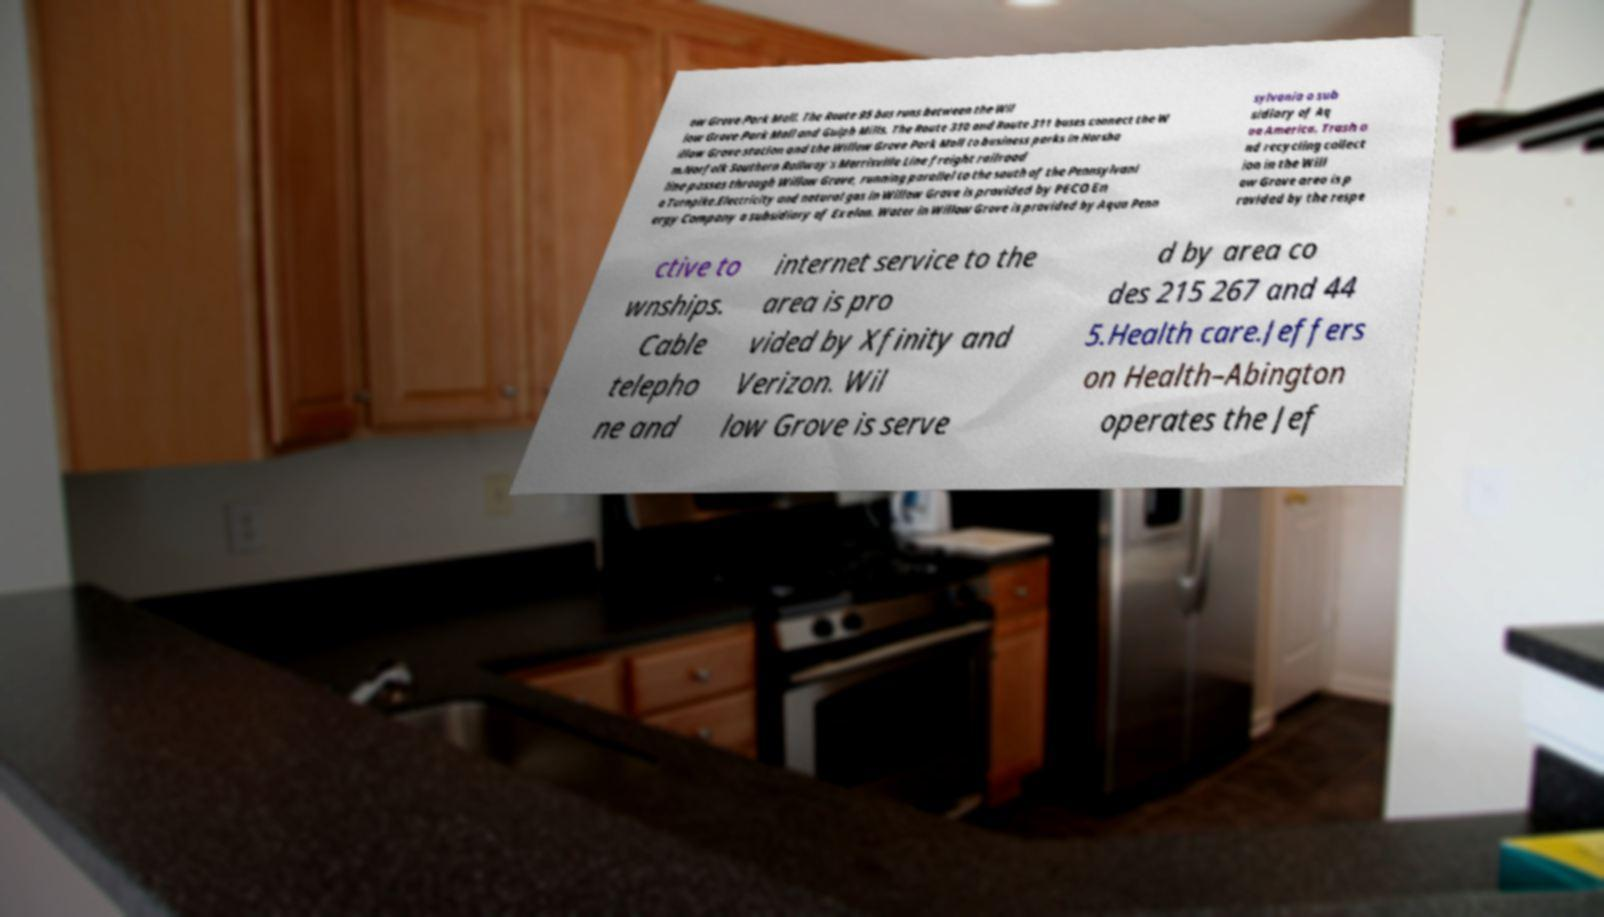What messages or text are displayed in this image? I need them in a readable, typed format. ow Grove Park Mall. The Route 95 bus runs between the Wil low Grove Park Mall and Gulph Mills. The Route 310 and Route 311 buses connect the W illow Grove station and the Willow Grove Park Mall to business parks in Horsha m.Norfolk Southern Railway's Morrisville Line freight railroad line passes through Willow Grove, running parallel to the south of the Pennsylvani a Turnpike.Electricity and natural gas in Willow Grove is provided by PECO En ergy Company a subsidiary of Exelon. Water in Willow Grove is provided by Aqua Penn sylvania a sub sidiary of Aq ua America. Trash a nd recycling collect ion in the Will ow Grove area is p rovided by the respe ctive to wnships. Cable telepho ne and internet service to the area is pro vided by Xfinity and Verizon. Wil low Grove is serve d by area co des 215 267 and 44 5.Health care.Jeffers on Health–Abington operates the Jef 